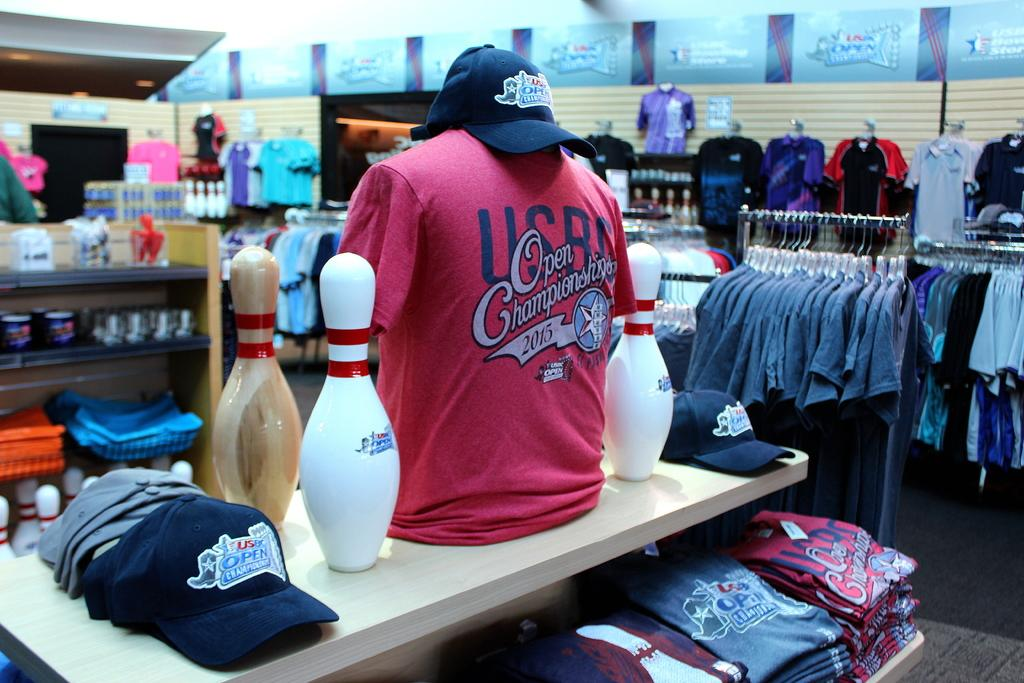<image>
Present a compact description of the photo's key features. a bowling display of tshirts and hats for the USBC Opening Champonship 2015 